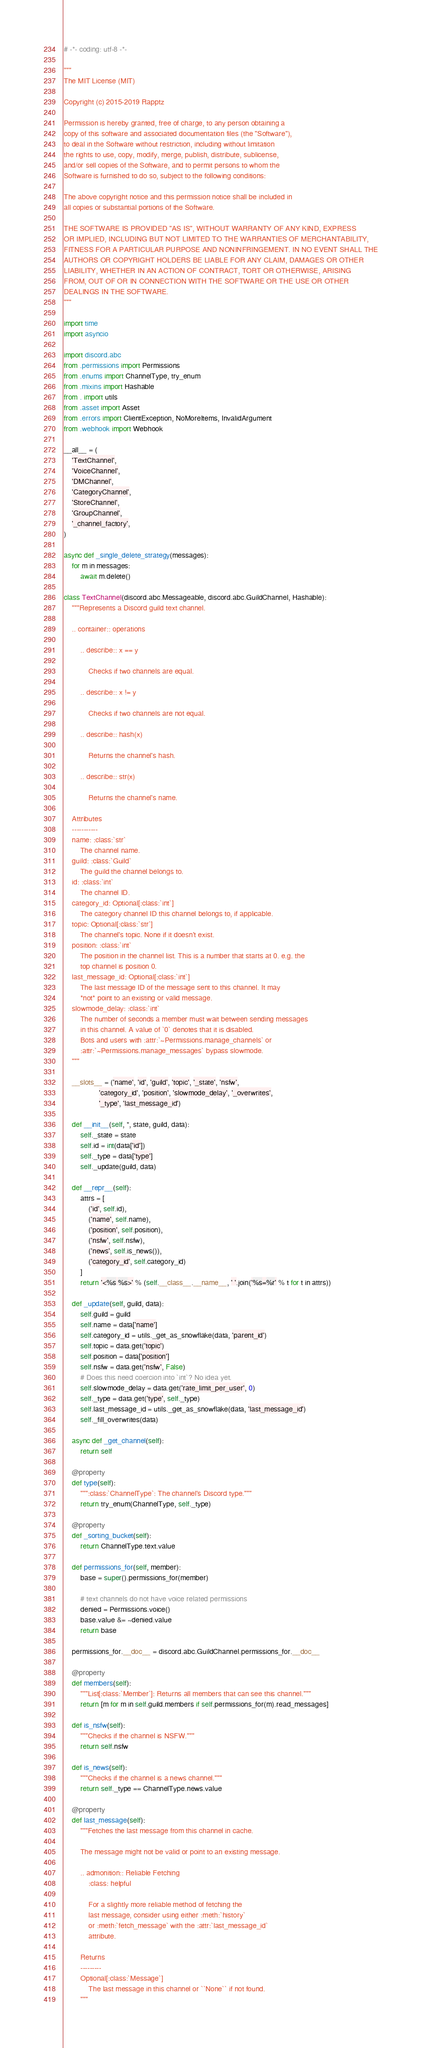<code> <loc_0><loc_0><loc_500><loc_500><_Python_># -*- coding: utf-8 -*-

"""
The MIT License (MIT)

Copyright (c) 2015-2019 Rapptz

Permission is hereby granted, free of charge, to any person obtaining a
copy of this software and associated documentation files (the "Software"),
to deal in the Software without restriction, including without limitation
the rights to use, copy, modify, merge, publish, distribute, sublicense,
and/or sell copies of the Software, and to permit persons to whom the
Software is furnished to do so, subject to the following conditions:

The above copyright notice and this permission notice shall be included in
all copies or substantial portions of the Software.

THE SOFTWARE IS PROVIDED "AS IS", WITHOUT WARRANTY OF ANY KIND, EXPRESS
OR IMPLIED, INCLUDING BUT NOT LIMITED TO THE WARRANTIES OF MERCHANTABILITY,
FITNESS FOR A PARTICULAR PURPOSE AND NONINFRINGEMENT. IN NO EVENT SHALL THE
AUTHORS OR COPYRIGHT HOLDERS BE LIABLE FOR ANY CLAIM, DAMAGES OR OTHER
LIABILITY, WHETHER IN AN ACTION OF CONTRACT, TORT OR OTHERWISE, ARISING
FROM, OUT OF OR IN CONNECTION WITH THE SOFTWARE OR THE USE OR OTHER
DEALINGS IN THE SOFTWARE.
"""

import time
import asyncio

import discord.abc
from .permissions import Permissions
from .enums import ChannelType, try_enum
from .mixins import Hashable
from . import utils
from .asset import Asset
from .errors import ClientException, NoMoreItems, InvalidArgument
from .webhook import Webhook

__all__ = (
    'TextChannel',
    'VoiceChannel',
    'DMChannel',
    'CategoryChannel',
    'StoreChannel',
    'GroupChannel',
    '_channel_factory',
)

async def _single_delete_strategy(messages):
    for m in messages:
        await m.delete()

class TextChannel(discord.abc.Messageable, discord.abc.GuildChannel, Hashable):
    """Represents a Discord guild text channel.

    .. container:: operations

        .. describe:: x == y

            Checks if two channels are equal.

        .. describe:: x != y

            Checks if two channels are not equal.

        .. describe:: hash(x)

            Returns the channel's hash.

        .. describe:: str(x)

            Returns the channel's name.

    Attributes
    -----------
    name: :class:`str`
        The channel name.
    guild: :class:`Guild`
        The guild the channel belongs to.
    id: :class:`int`
        The channel ID.
    category_id: Optional[:class:`int`]
        The category channel ID this channel belongs to, if applicable.
    topic: Optional[:class:`str`]
        The channel's topic. None if it doesn't exist.
    position: :class:`int`
        The position in the channel list. This is a number that starts at 0. e.g. the
        top channel is position 0.
    last_message_id: Optional[:class:`int`]
        The last message ID of the message sent to this channel. It may
        *not* point to an existing or valid message.
    slowmode_delay: :class:`int`
        The number of seconds a member must wait between sending messages
        in this channel. A value of `0` denotes that it is disabled.
        Bots and users with :attr:`~Permissions.manage_channels` or
        :attr:`~Permissions.manage_messages` bypass slowmode.
    """

    __slots__ = ('name', 'id', 'guild', 'topic', '_state', 'nsfw',
                 'category_id', 'position', 'slowmode_delay', '_overwrites',
                 '_type', 'last_message_id')

    def __init__(self, *, state, guild, data):
        self._state = state
        self.id = int(data['id'])
        self._type = data['type']
        self._update(guild, data)

    def __repr__(self):
        attrs = [
            ('id', self.id),
            ('name', self.name),
            ('position', self.position),
            ('nsfw', self.nsfw),
            ('news', self.is_news()),
            ('category_id', self.category_id)
        ]
        return '<%s %s>' % (self.__class__.__name__, ' '.join('%s=%r' % t for t in attrs))

    def _update(self, guild, data):
        self.guild = guild
        self.name = data['name']
        self.category_id = utils._get_as_snowflake(data, 'parent_id')
        self.topic = data.get('topic')
        self.position = data['position']
        self.nsfw = data.get('nsfw', False)
        # Does this need coercion into `int`? No idea yet.
        self.slowmode_delay = data.get('rate_limit_per_user', 0)
        self._type = data.get('type', self._type)
        self.last_message_id = utils._get_as_snowflake(data, 'last_message_id')
        self._fill_overwrites(data)

    async def _get_channel(self):
        return self

    @property
    def type(self):
        """:class:`ChannelType`: The channel's Discord type."""
        return try_enum(ChannelType, self._type)

    @property
    def _sorting_bucket(self):
        return ChannelType.text.value

    def permissions_for(self, member):
        base = super().permissions_for(member)

        # text channels do not have voice related permissions
        denied = Permissions.voice()
        base.value &= ~denied.value
        return base

    permissions_for.__doc__ = discord.abc.GuildChannel.permissions_for.__doc__

    @property
    def members(self):
        """List[:class:`Member`]: Returns all members that can see this channel."""
        return [m for m in self.guild.members if self.permissions_for(m).read_messages]

    def is_nsfw(self):
        """Checks if the channel is NSFW."""
        return self.nsfw

    def is_news(self):
        """Checks if the channel is a news channel."""
        return self._type == ChannelType.news.value

    @property
    def last_message(self):
        """Fetches the last message from this channel in cache.

        The message might not be valid or point to an existing message.

        .. admonition:: Reliable Fetching
            :class: helpful

            For a slightly more reliable method of fetching the
            last message, consider using either :meth:`history`
            or :meth:`fetch_message` with the :attr:`last_message_id`
            attribute.

        Returns
        ---------
        Optional[:class:`Message`]
            The last message in this channel or ``None`` if not found.
        """</code> 